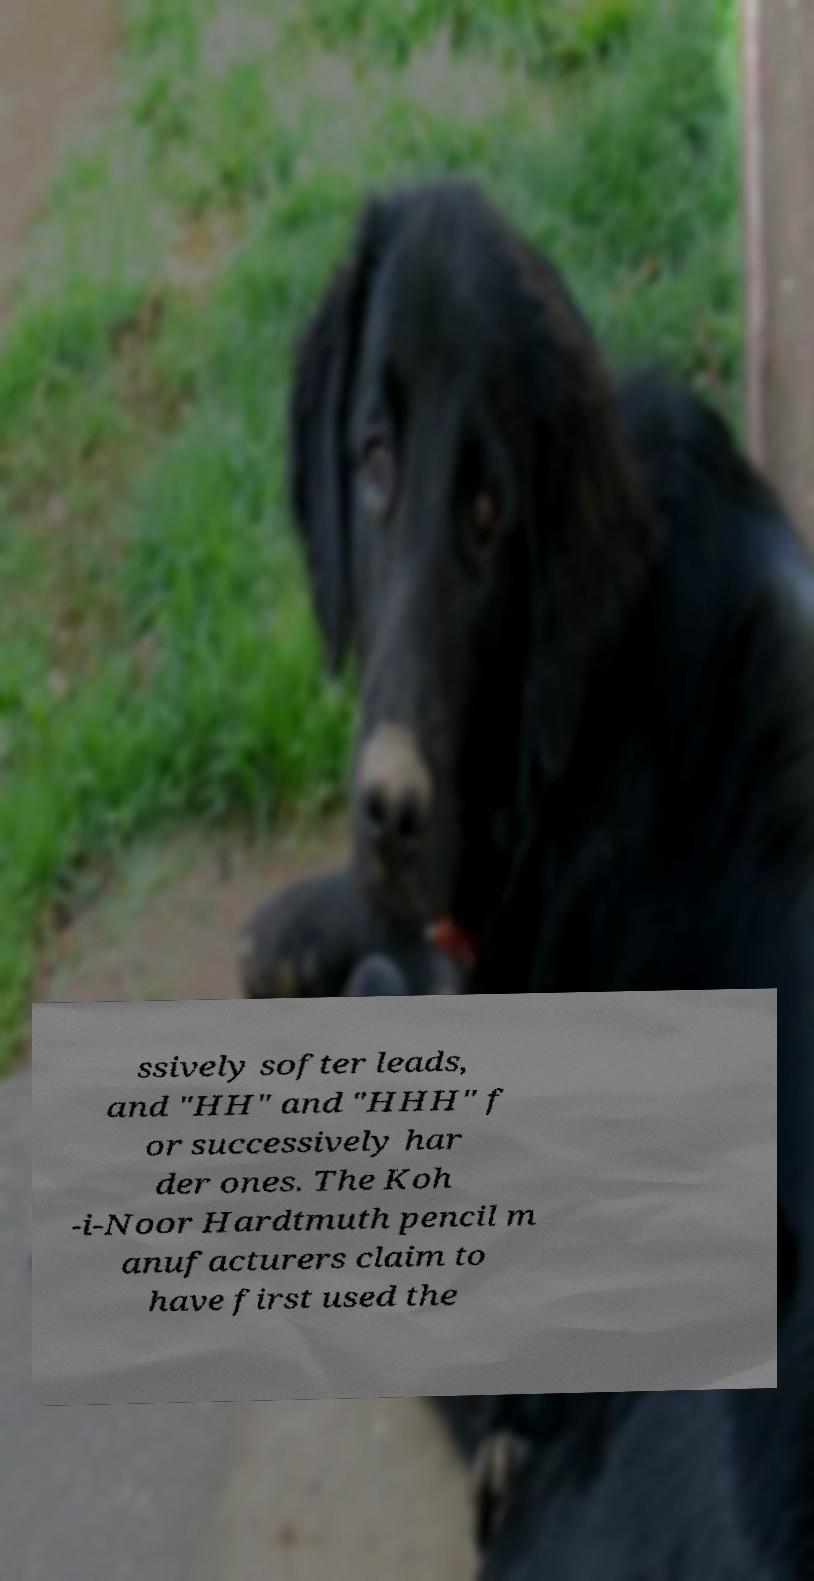What messages or text are displayed in this image? I need them in a readable, typed format. ssively softer leads, and "HH" and "HHH" f or successively har der ones. The Koh -i-Noor Hardtmuth pencil m anufacturers claim to have first used the 